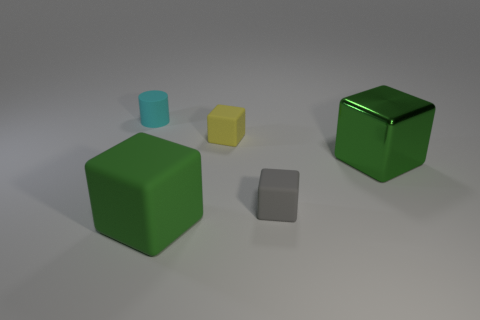How many green blocks must be subtracted to get 1 green blocks? 1 Subtract all big shiny blocks. How many blocks are left? 3 Subtract all purple balls. How many green blocks are left? 2 Subtract all cylinders. How many objects are left? 4 Add 5 green objects. How many objects exist? 10 Subtract 1 cylinders. How many cylinders are left? 0 Subtract all yellow cubes. How many cubes are left? 3 Add 1 tiny green matte cylinders. How many tiny green matte cylinders exist? 1 Subtract 0 green spheres. How many objects are left? 5 Subtract all cyan blocks. Subtract all gray cylinders. How many blocks are left? 4 